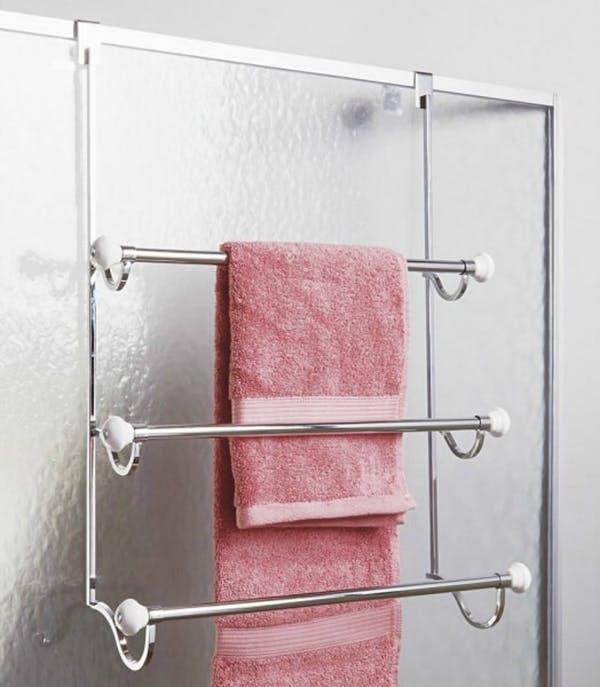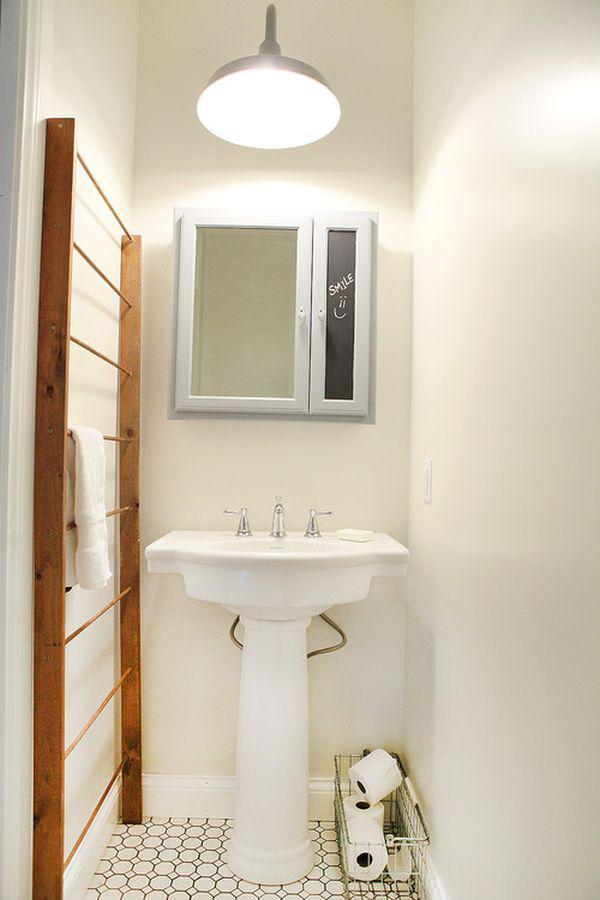The first image is the image on the left, the second image is the image on the right. Evaluate the accuracy of this statement regarding the images: "There is no more than three towels.". Is it true? Answer yes or no. Yes. The first image is the image on the left, the second image is the image on the right. Examine the images to the left and right. Is the description "In the image to the right, there are flowers on the bathroom counter." accurate? Answer yes or no. No. 